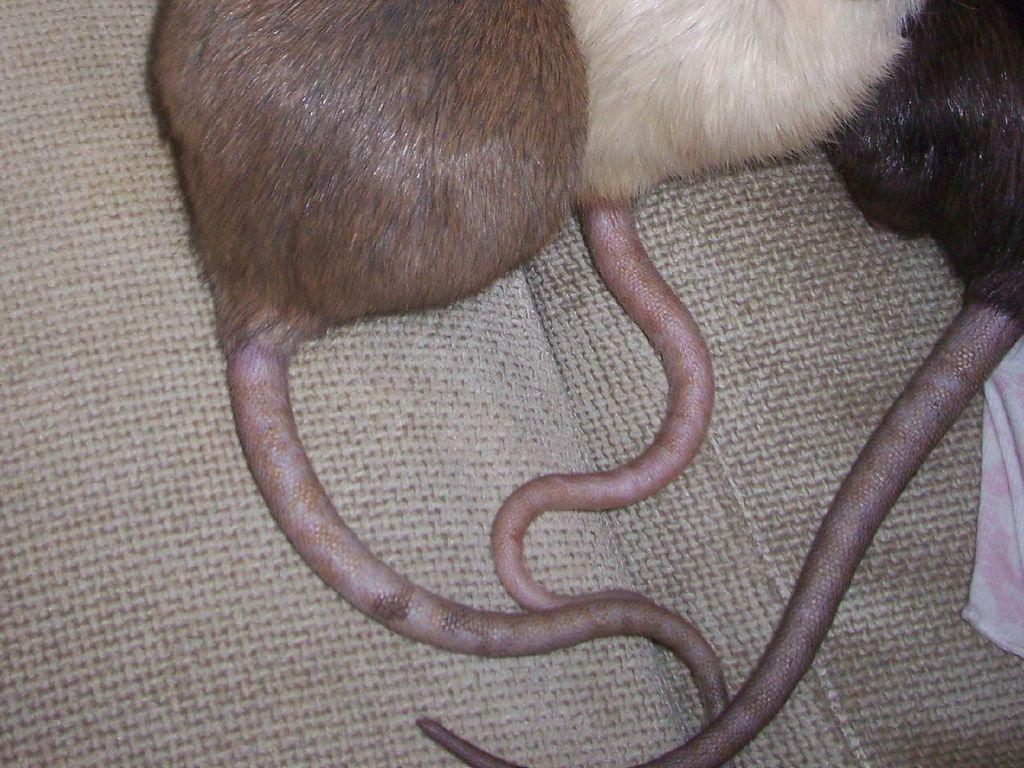What type of animals can be seen in the image? There are animals with tails in the image, and they resemble rats. What is the color of the cloth on the right side of the image? The cloth on the right side of the image is white. What type of advertisement is displayed on the white cloth in the image? There is no advertisement present on the white cloth in the image; it is just a plain white cloth. 